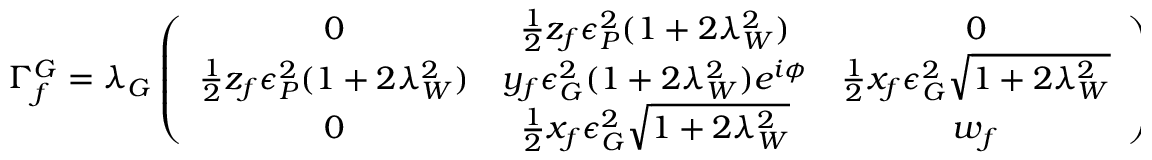Convert formula to latex. <formula><loc_0><loc_0><loc_500><loc_500>\Gamma _ { f } ^ { G } = \lambda _ { G } \left ( \begin{array} { c c c } { 0 } & { { \frac { 1 } { 2 } z _ { f } \epsilon _ { P } ^ { 2 } ( 1 + 2 \lambda _ { W } ^ { 2 } ) } } & { 0 } \\ { { \frac { 1 } { 2 } z _ { f } \epsilon _ { P } ^ { 2 } ( 1 + 2 \lambda _ { W } ^ { 2 } ) } } & { { y _ { f } \epsilon _ { G } ^ { 2 } ( 1 + 2 \lambda _ { W } ^ { 2 } ) e ^ { i \phi } } } & { { \frac { 1 } { 2 } x _ { f } \epsilon _ { G } ^ { 2 } \sqrt { 1 + 2 \lambda _ { W } ^ { 2 } } } } \\ { 0 } & { { \frac { 1 } { 2 } x _ { f } \epsilon _ { G } ^ { 2 } \sqrt { 1 + 2 \lambda _ { W } ^ { 2 } } } } & { { w _ { f } } } \end{array} \right )</formula> 